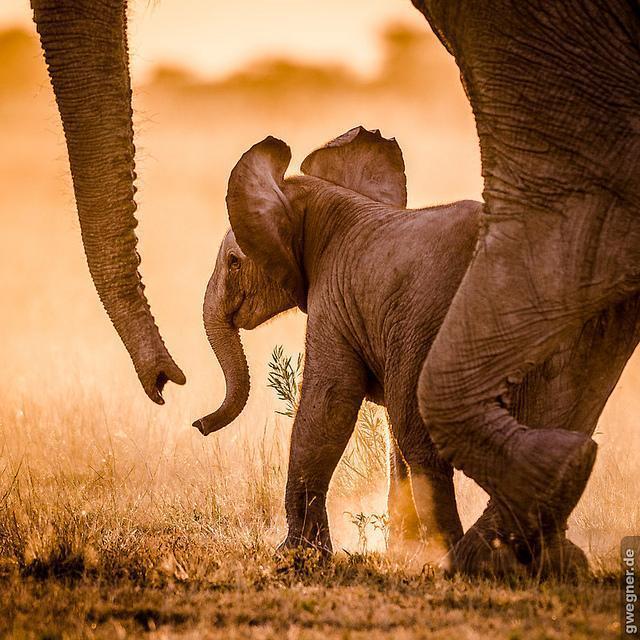How many elephants are visible?
Give a very brief answer. 2. How many bears are fully visible?
Give a very brief answer. 0. 